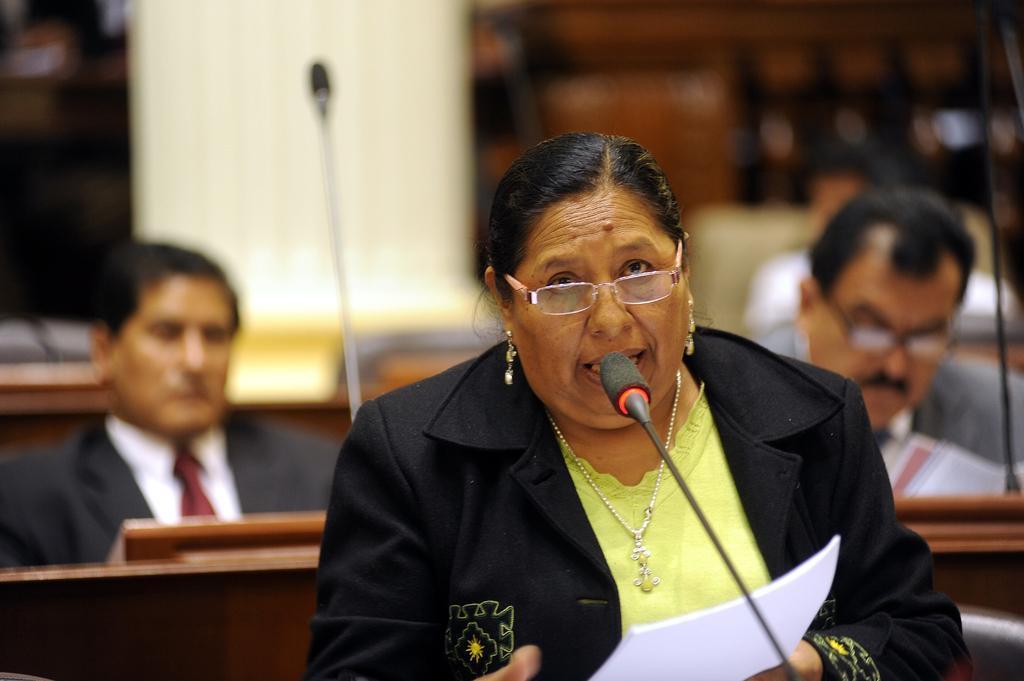Please provide a concise description of this image. In this picture there is a woman talking and holding the paper. In the foreground there is a microphone. At the back there are three people sitting and there are microphones on the tables and the image is blurry. 